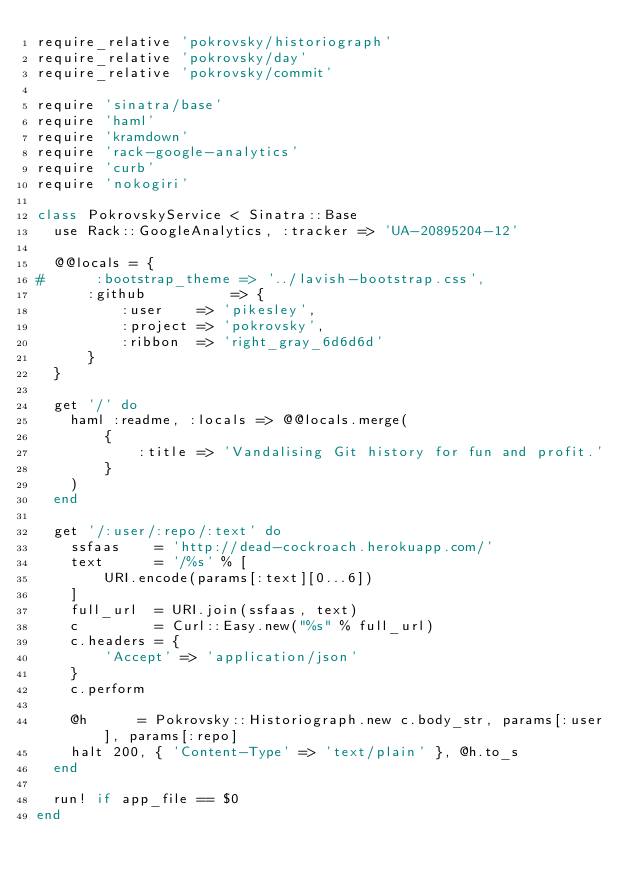Convert code to text. <code><loc_0><loc_0><loc_500><loc_500><_Ruby_>require_relative 'pokrovsky/historiograph'
require_relative 'pokrovsky/day'
require_relative 'pokrovsky/commit'

require 'sinatra/base'
require 'haml'
require 'kramdown'
require 'rack-google-analytics'
require 'curb'
require 'nokogiri'

class PokrovskyService < Sinatra::Base
  use Rack::GoogleAnalytics, :tracker => 'UA-20895204-12'

  @@locals = {
#      :bootstrap_theme => '../lavish-bootstrap.css',
      :github          => {
          :user    => 'pikesley',
          :project => 'pokrovsky',
          :ribbon  => 'right_gray_6d6d6d'
      }
  }

  get '/' do
    haml :readme, :locals => @@locals.merge(
        {
            :title => 'Vandalising Git history for fun and profit.'
        }
    )
  end

  get '/:user/:repo/:text' do
    ssfaas    = 'http://dead-cockroach.herokuapp.com/'
    text      = '/%s' % [
        URI.encode(params[:text][0...6])
    ]
    full_url  = URI.join(ssfaas, text)
    c         = Curl::Easy.new("%s" % full_url)
    c.headers = {
        'Accept' => 'application/json'
    }
    c.perform

    @h      = Pokrovsky::Historiograph.new c.body_str, params[:user], params[:repo]
    halt 200, { 'Content-Type' => 'text/plain' }, @h.to_s
  end

  run! if app_file == $0
end
</code> 